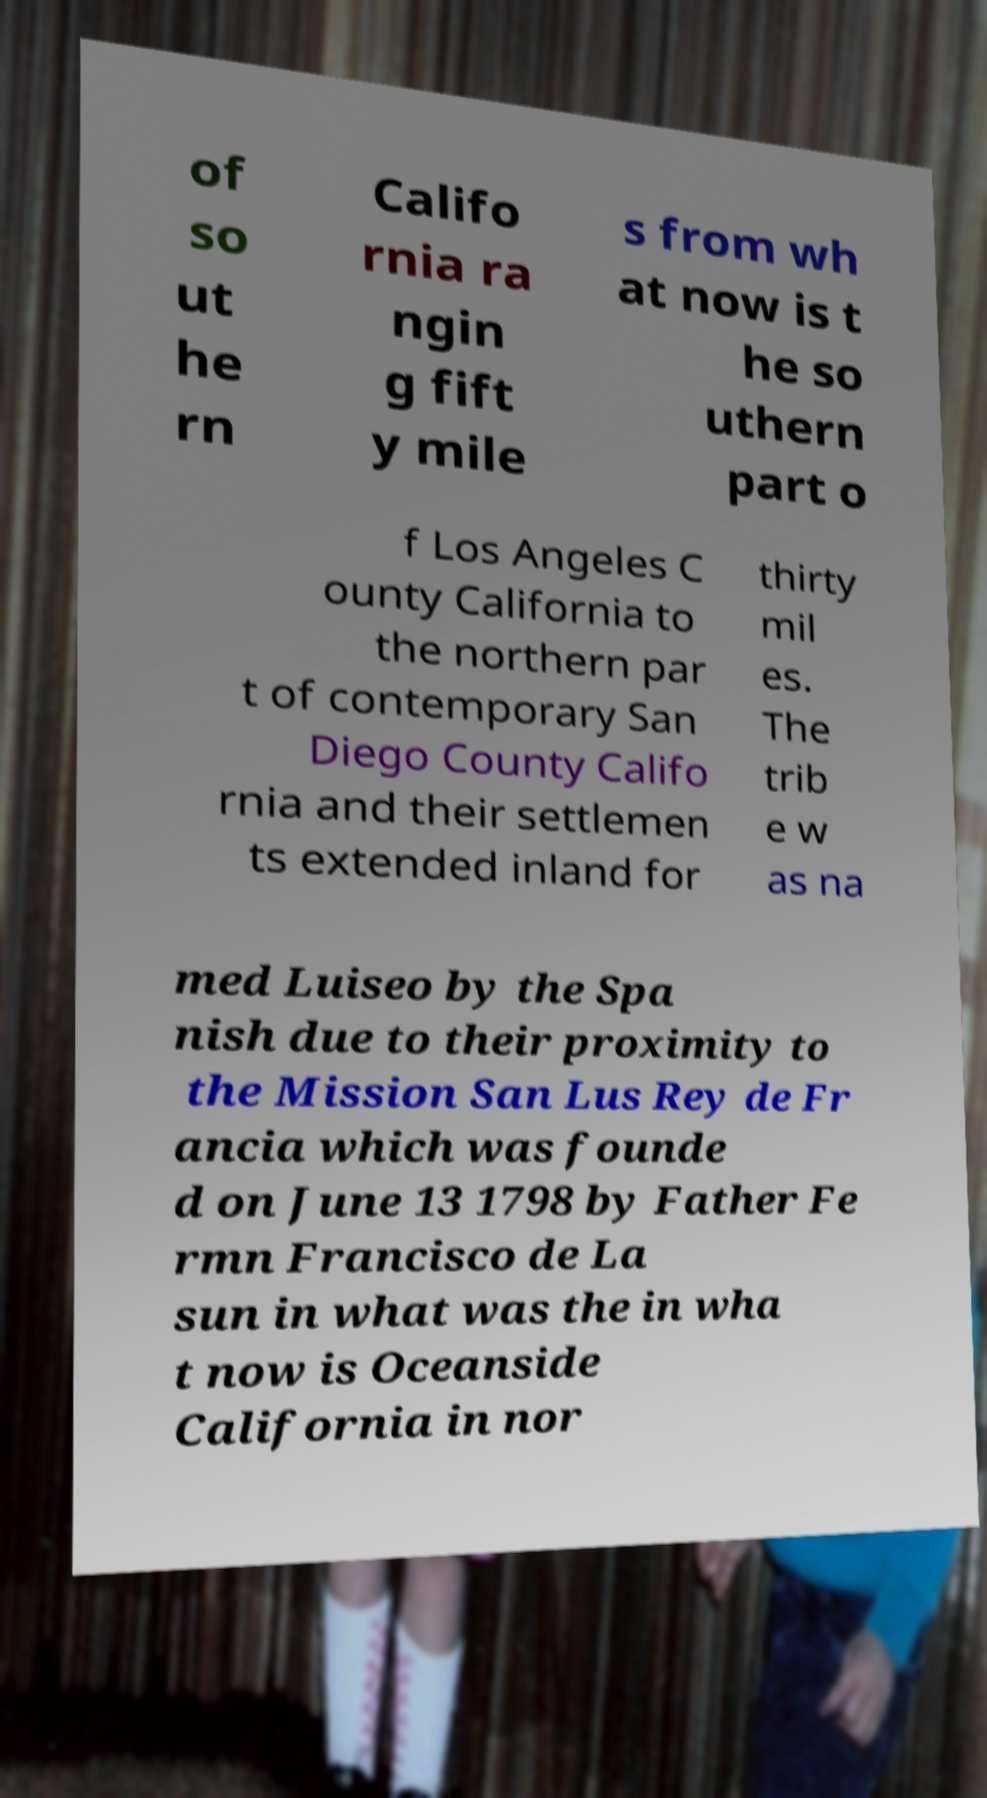Please read and relay the text visible in this image. What does it say? of so ut he rn Califo rnia ra ngin g fift y mile s from wh at now is t he so uthern part o f Los Angeles C ounty California to the northern par t of contemporary San Diego County Califo rnia and their settlemen ts extended inland for thirty mil es. The trib e w as na med Luiseo by the Spa nish due to their proximity to the Mission San Lus Rey de Fr ancia which was founde d on June 13 1798 by Father Fe rmn Francisco de La sun in what was the in wha t now is Oceanside California in nor 